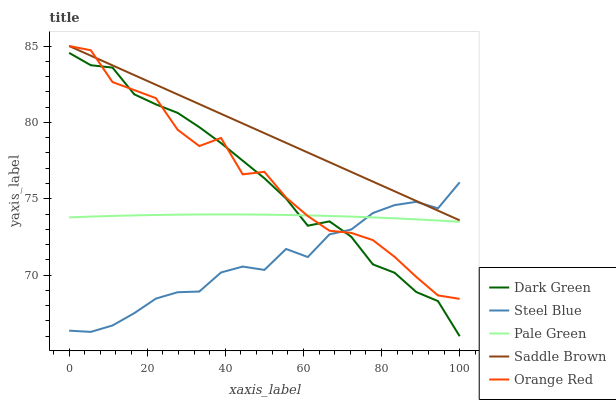Does Steel Blue have the minimum area under the curve?
Answer yes or no. Yes. Does Saddle Brown have the maximum area under the curve?
Answer yes or no. Yes. Does Pale Green have the minimum area under the curve?
Answer yes or no. No. Does Pale Green have the maximum area under the curve?
Answer yes or no. No. Is Saddle Brown the smoothest?
Answer yes or no. Yes. Is Orange Red the roughest?
Answer yes or no. Yes. Is Pale Green the smoothest?
Answer yes or no. No. Is Pale Green the roughest?
Answer yes or no. No. Does Dark Green have the lowest value?
Answer yes or no. Yes. Does Pale Green have the lowest value?
Answer yes or no. No. Does Orange Red have the highest value?
Answer yes or no. Yes. Does Steel Blue have the highest value?
Answer yes or no. No. Is Dark Green less than Saddle Brown?
Answer yes or no. Yes. Is Saddle Brown greater than Pale Green?
Answer yes or no. Yes. Does Dark Green intersect Pale Green?
Answer yes or no. Yes. Is Dark Green less than Pale Green?
Answer yes or no. No. Is Dark Green greater than Pale Green?
Answer yes or no. No. Does Dark Green intersect Saddle Brown?
Answer yes or no. No. 